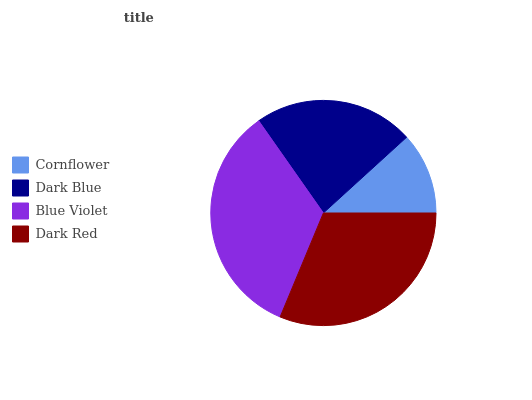Is Cornflower the minimum?
Answer yes or no. Yes. Is Blue Violet the maximum?
Answer yes or no. Yes. Is Dark Blue the minimum?
Answer yes or no. No. Is Dark Blue the maximum?
Answer yes or no. No. Is Dark Blue greater than Cornflower?
Answer yes or no. Yes. Is Cornflower less than Dark Blue?
Answer yes or no. Yes. Is Cornflower greater than Dark Blue?
Answer yes or no. No. Is Dark Blue less than Cornflower?
Answer yes or no. No. Is Dark Red the high median?
Answer yes or no. Yes. Is Dark Blue the low median?
Answer yes or no. Yes. Is Dark Blue the high median?
Answer yes or no. No. Is Dark Red the low median?
Answer yes or no. No. 